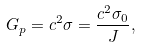Convert formula to latex. <formula><loc_0><loc_0><loc_500><loc_500>G _ { p } = c ^ { 2 } \sigma = \frac { c ^ { 2 } \sigma _ { 0 } } { J } ,</formula> 